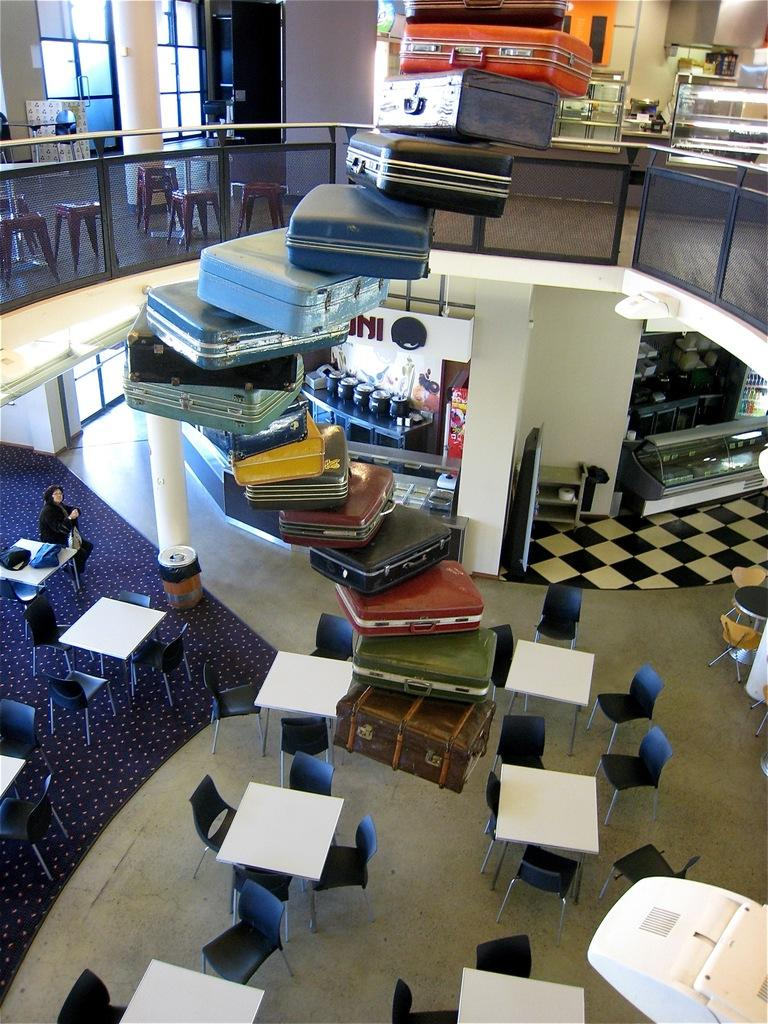What type of area is depicted in the image? The image appears to be a food court area. What furniture is present in the image? There are many chairs and tables in the image. What objects can be seen in the middle of the image? There are suitcases in the middle of the image. Can you describe any architectural features in the image? Yes, there is a staircase in the image. What type of organization is hosting an event in the food court area? There is no indication of an event or organization in the image. Can you see any bears interacting with the suitcases in the image? No, there are no bears present in the image. 